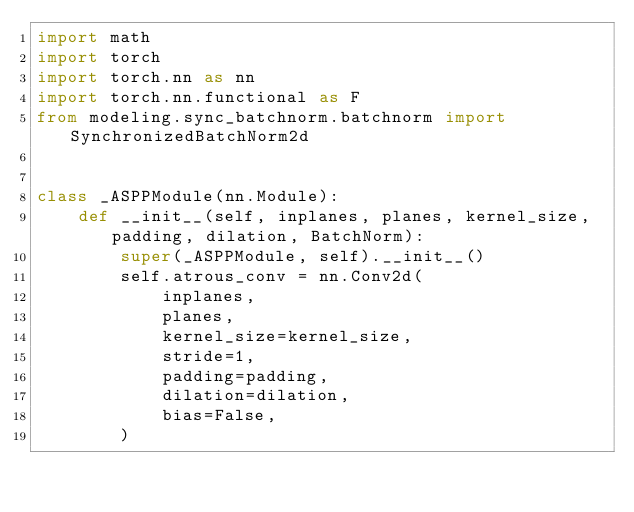<code> <loc_0><loc_0><loc_500><loc_500><_Python_>import math
import torch
import torch.nn as nn
import torch.nn.functional as F
from modeling.sync_batchnorm.batchnorm import SynchronizedBatchNorm2d


class _ASPPModule(nn.Module):
    def __init__(self, inplanes, planes, kernel_size, padding, dilation, BatchNorm):
        super(_ASPPModule, self).__init__()
        self.atrous_conv = nn.Conv2d(
            inplanes,
            planes,
            kernel_size=kernel_size,
            stride=1,
            padding=padding,
            dilation=dilation,
            bias=False,
        )</code> 